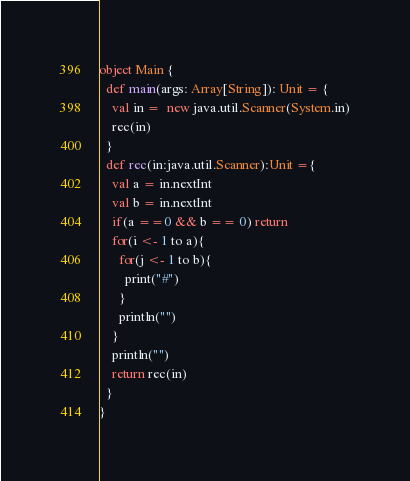Convert code to text. <code><loc_0><loc_0><loc_500><loc_500><_Scala_>
object Main {
  def main(args: Array[String]): Unit = {
    val in =  new java.util.Scanner(System.in)
    rec(in)
  }
  def rec(in:java.util.Scanner):Unit ={
    val a = in.nextInt
    val b = in.nextInt
    if(a ==0 && b == 0) return
    for(i <- 1 to a){
      for(j <- 1 to b){
        print("#")
      }
      println("")
    }
    println("")
    return rec(in)
  }
}</code> 